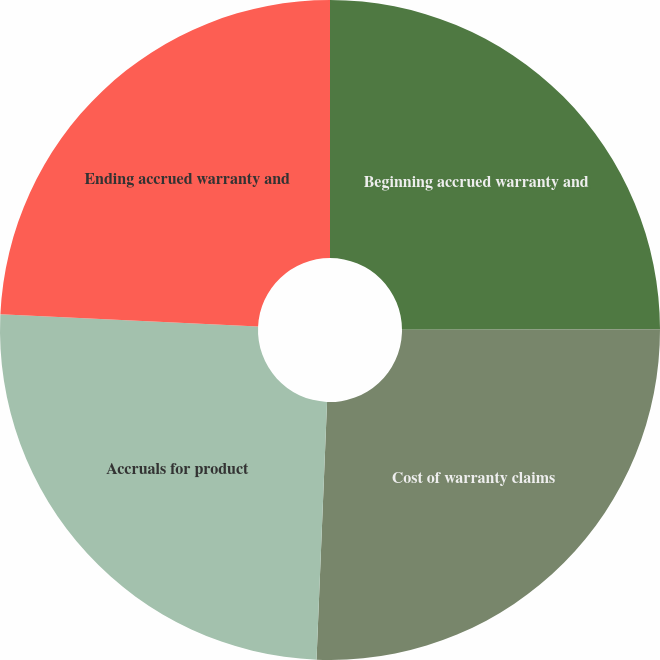Convert chart to OTSL. <chart><loc_0><loc_0><loc_500><loc_500><pie_chart><fcel>Beginning accrued warranty and<fcel>Cost of warranty claims<fcel>Accruals for product<fcel>Ending accrued warranty and<nl><fcel>24.96%<fcel>25.69%<fcel>25.11%<fcel>24.24%<nl></chart> 